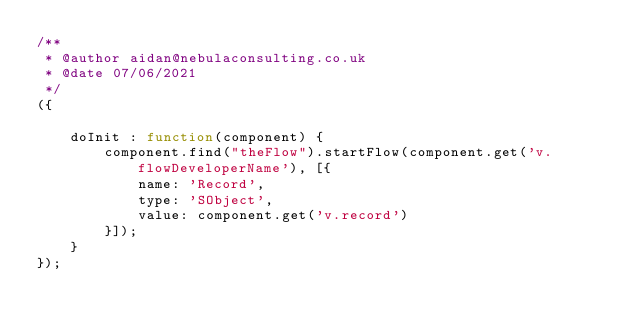<code> <loc_0><loc_0><loc_500><loc_500><_JavaScript_>/**
 * @author aidan@nebulaconsulting.co.uk
 * @date 07/06/2021
 */
({

    doInit : function(component) {
        component.find("theFlow").startFlow(component.get('v.flowDeveloperName'), [{
            name: 'Record',
            type: 'SObject',
            value: component.get('v.record')
        }]);
    }
});</code> 